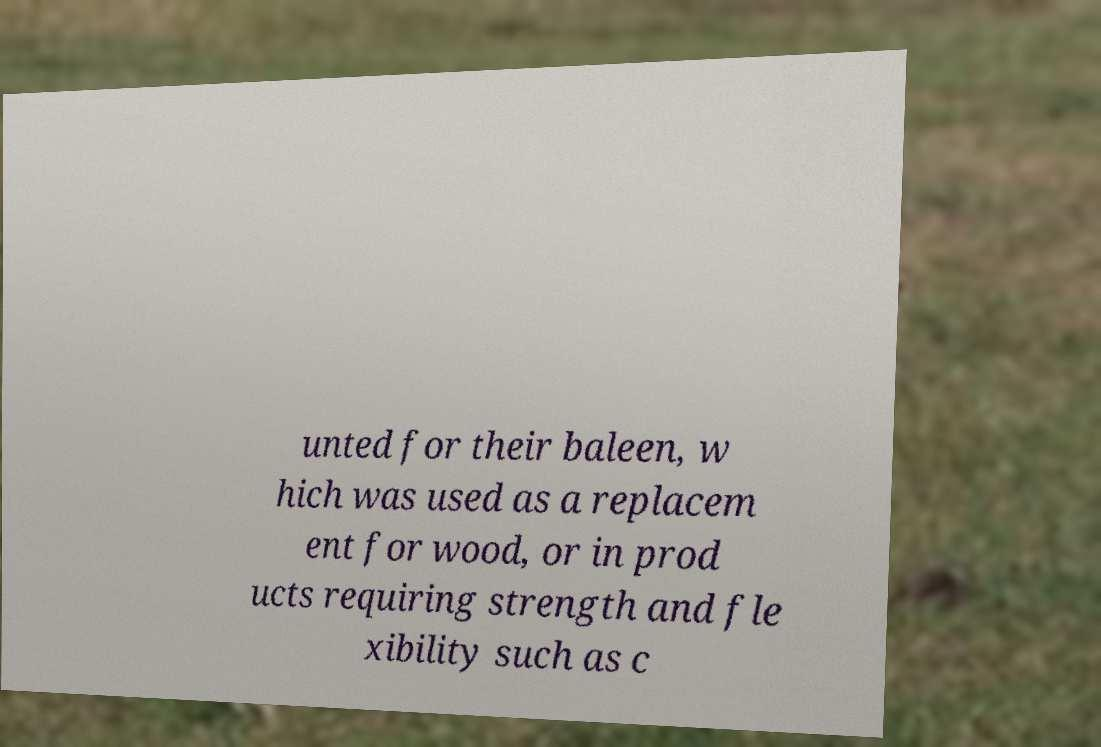What messages or text are displayed in this image? I need them in a readable, typed format. unted for their baleen, w hich was used as a replacem ent for wood, or in prod ucts requiring strength and fle xibility such as c 